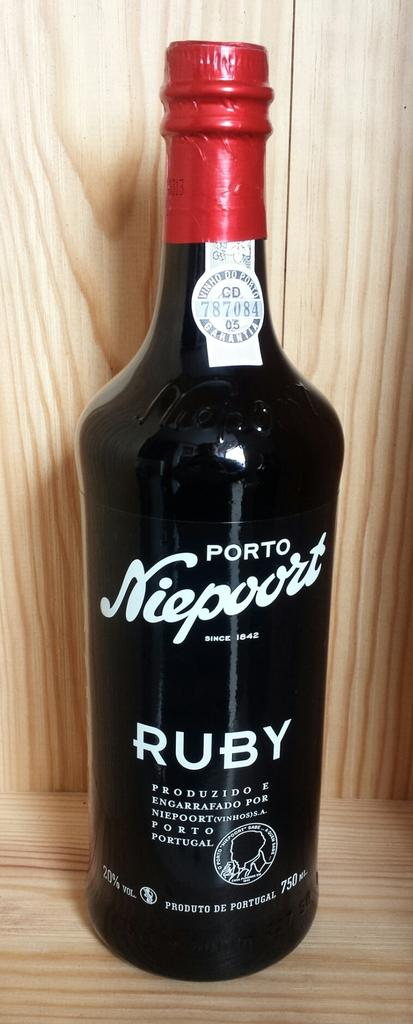<image>
Summarize the visual content of the image. A bottle of Portp Niepoort Ruby is sitting in a wooden box. 